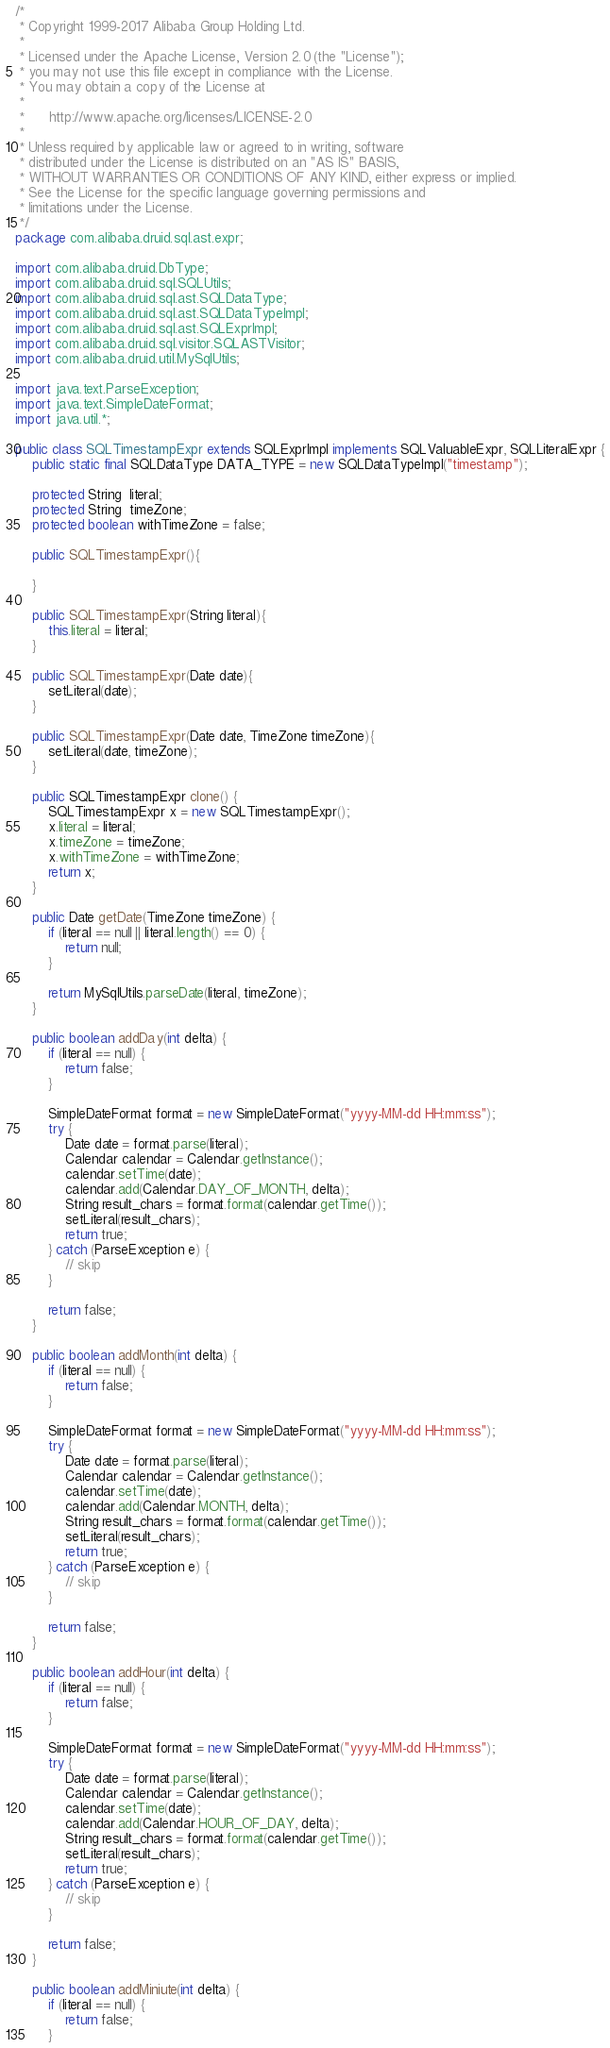<code> <loc_0><loc_0><loc_500><loc_500><_Java_>/*
 * Copyright 1999-2017 Alibaba Group Holding Ltd.
 *
 * Licensed under the Apache License, Version 2.0 (the "License");
 * you may not use this file except in compliance with the License.
 * You may obtain a copy of the License at
 *
 *      http://www.apache.org/licenses/LICENSE-2.0
 *
 * Unless required by applicable law or agreed to in writing, software
 * distributed under the License is distributed on an "AS IS" BASIS,
 * WITHOUT WARRANTIES OR CONDITIONS OF ANY KIND, either express or implied.
 * See the License for the specific language governing permissions and
 * limitations under the License.
 */
package com.alibaba.druid.sql.ast.expr;

import com.alibaba.druid.DbType;
import com.alibaba.druid.sql.SQLUtils;
import com.alibaba.druid.sql.ast.SQLDataType;
import com.alibaba.druid.sql.ast.SQLDataTypeImpl;
import com.alibaba.druid.sql.ast.SQLExprImpl;
import com.alibaba.druid.sql.visitor.SQLASTVisitor;
import com.alibaba.druid.util.MySqlUtils;

import java.text.ParseException;
import java.text.SimpleDateFormat;
import java.util.*;

public class SQLTimestampExpr extends SQLExprImpl implements SQLValuableExpr, SQLLiteralExpr {
    public static final SQLDataType DATA_TYPE = new SQLDataTypeImpl("timestamp");

    protected String  literal;
    protected String  timeZone;
    protected boolean withTimeZone = false;

    public SQLTimestampExpr(){
        
    }

    public SQLTimestampExpr(String literal){
        this.literal = literal;
    }

    public SQLTimestampExpr(Date date){
        setLiteral(date);
    }

    public SQLTimestampExpr(Date date, TimeZone timeZone){
        setLiteral(date, timeZone);
    }

    public SQLTimestampExpr clone() {
        SQLTimestampExpr x = new SQLTimestampExpr();
        x.literal = literal;
        x.timeZone = timeZone;
        x.withTimeZone = withTimeZone;
        return x;
    }

    public Date getDate(TimeZone timeZone) {
        if (literal == null || literal.length() == 0) {
            return null;
        }

        return MySqlUtils.parseDate(literal, timeZone);
    }

    public boolean addDay(int delta) {
        if (literal == null) {
            return false;
        }

        SimpleDateFormat format = new SimpleDateFormat("yyyy-MM-dd HH:mm:ss");
        try {
            Date date = format.parse(literal);
            Calendar calendar = Calendar.getInstance();
            calendar.setTime(date);
            calendar.add(Calendar.DAY_OF_MONTH, delta);
            String result_chars = format.format(calendar.getTime());
            setLiteral(result_chars);
            return true;
        } catch (ParseException e) {
            // skip
        }

        return false;
    }

    public boolean addMonth(int delta) {
        if (literal == null) {
            return false;
        }

        SimpleDateFormat format = new SimpleDateFormat("yyyy-MM-dd HH:mm:ss");
        try {
            Date date = format.parse(literal);
            Calendar calendar = Calendar.getInstance();
            calendar.setTime(date);
            calendar.add(Calendar.MONTH, delta);
            String result_chars = format.format(calendar.getTime());
            setLiteral(result_chars);
            return true;
        } catch (ParseException e) {
            // skip
        }

        return false;
    }

    public boolean addHour(int delta) {
        if (literal == null) {
            return false;
        }

        SimpleDateFormat format = new SimpleDateFormat("yyyy-MM-dd HH:mm:ss");
        try {
            Date date = format.parse(literal);
            Calendar calendar = Calendar.getInstance();
            calendar.setTime(date);
            calendar.add(Calendar.HOUR_OF_DAY, delta);
            String result_chars = format.format(calendar.getTime());
            setLiteral(result_chars);
            return true;
        } catch (ParseException e) {
            // skip
        }

        return false;
    }

    public boolean addMiniute(int delta) {
        if (literal == null) {
            return false;
        }
</code> 